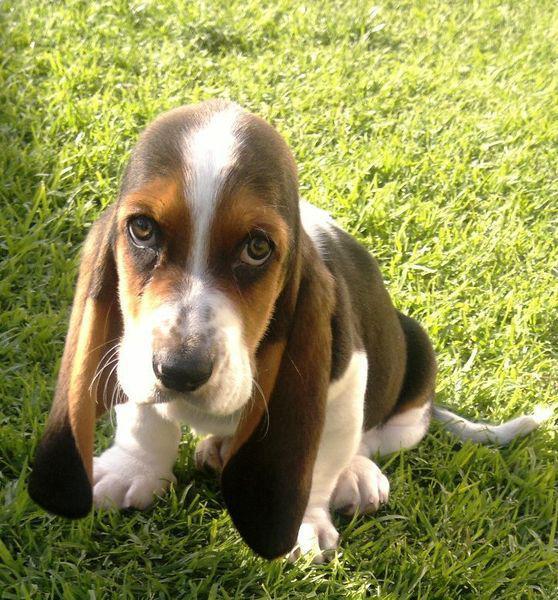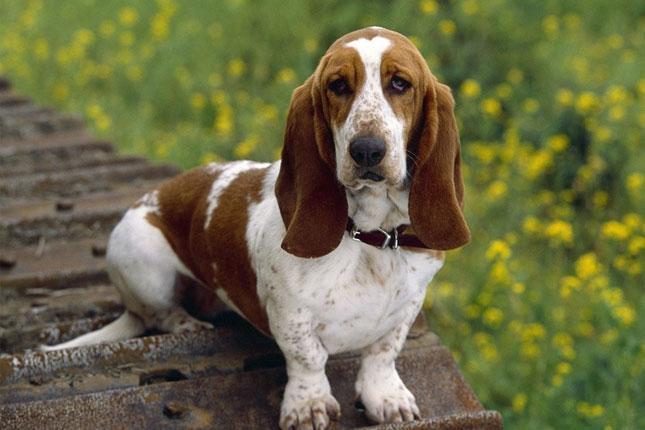The first image is the image on the left, the second image is the image on the right. For the images displayed, is the sentence "One image shows a basset hound being touched by a human hand." factually correct? Answer yes or no. No. The first image is the image on the left, the second image is the image on the right. For the images shown, is this caption "One of the dogs is right next to a human, and being touched by the human." true? Answer yes or no. No. 